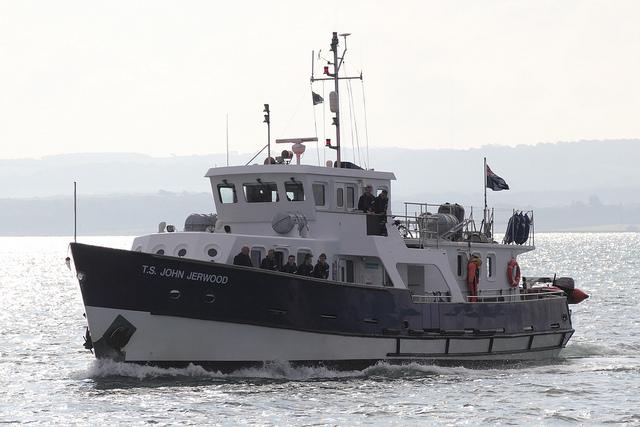How many letters are in the ship's name?
Give a very brief answer. 13. What two colors are this boat?
Short answer required. Blue and white. Is the water calm?
Concise answer only. Yes. 